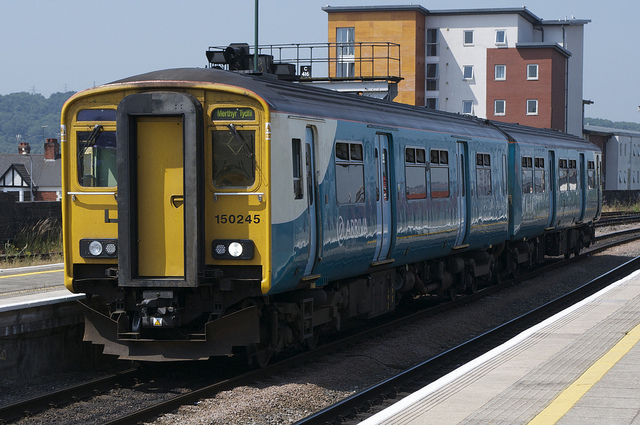Extract all visible text content from this image. 150245 